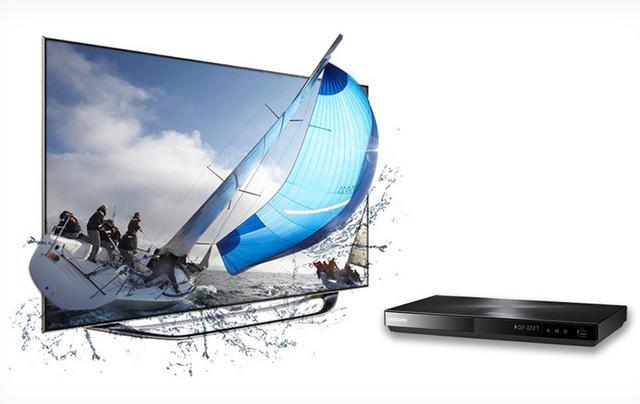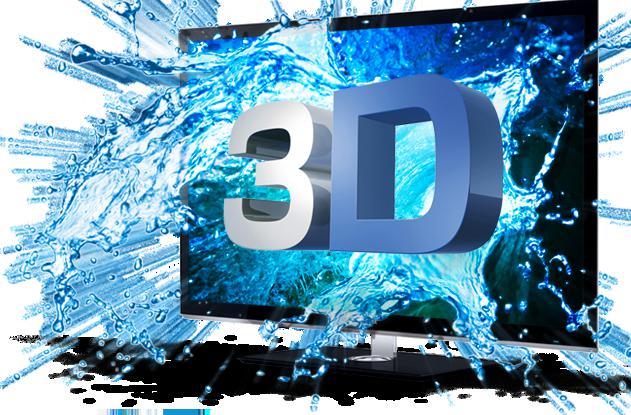The first image is the image on the left, the second image is the image on the right. For the images shown, is this caption "There is a vehicle flying in the air on the screen of one of the monitors." true? Answer yes or no. No. The first image is the image on the left, the second image is the image on the right. Examine the images to the left and right. Is the description "One of the TVs shows a type of aircraft on the screen, with part of the vehicle extending off the screen." accurate? Answer yes or no. No. 